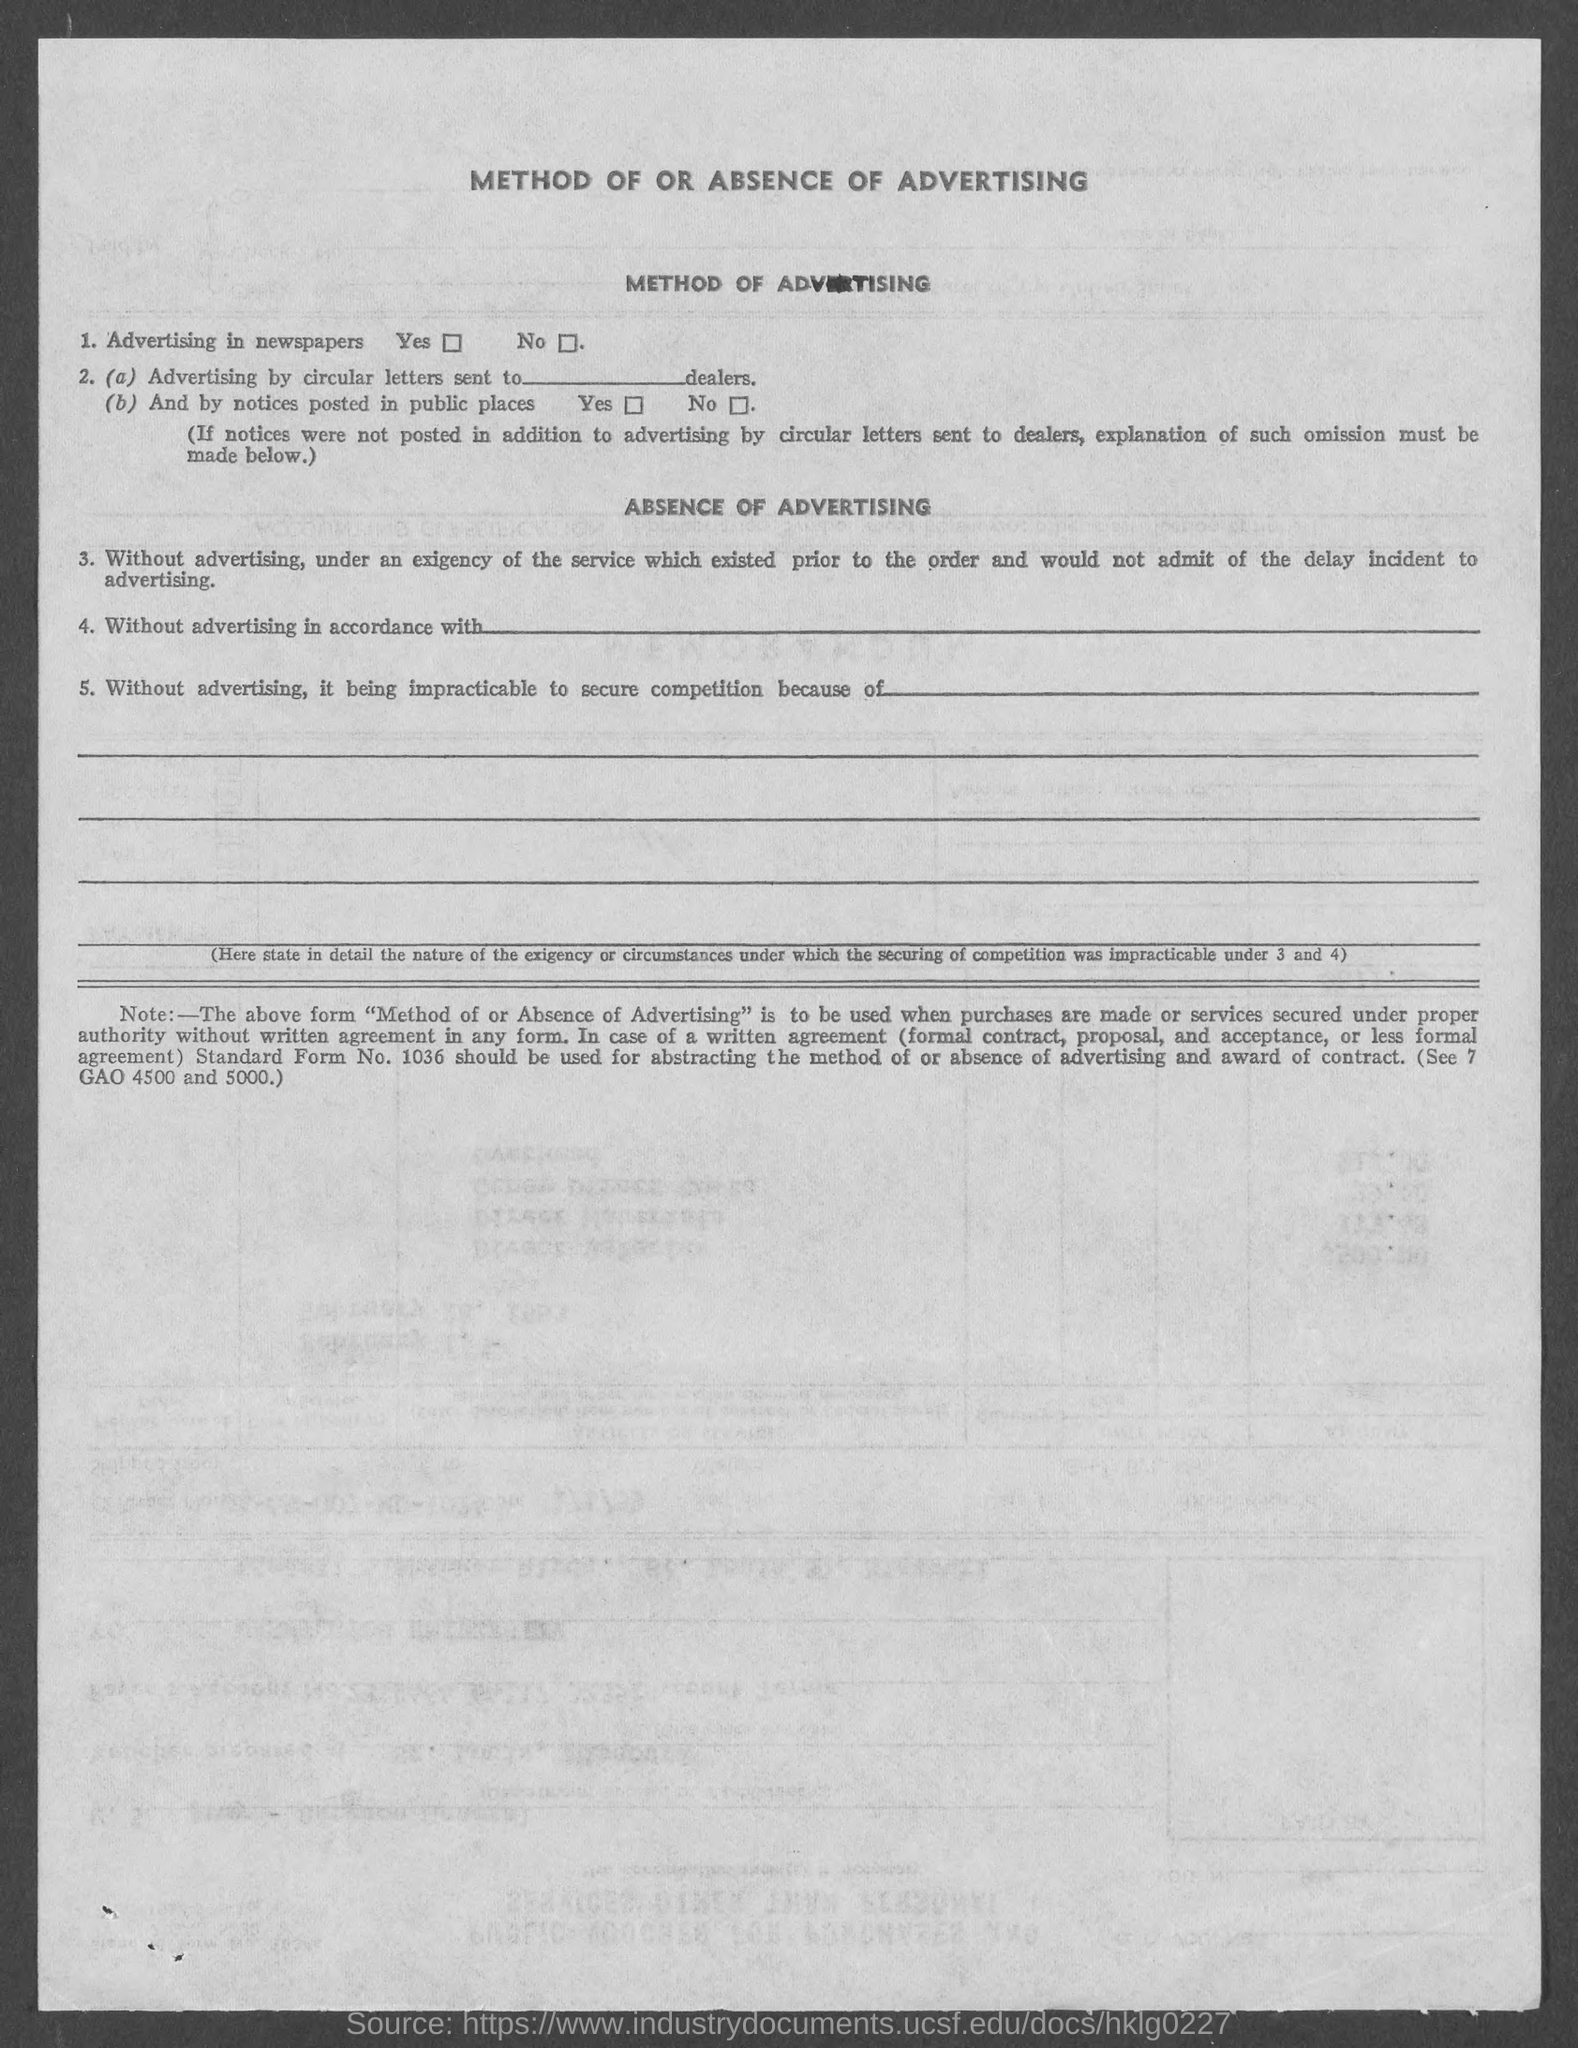Point out several critical features in this image. The title of this document is 'The Method of or Absence of Advertising'. 